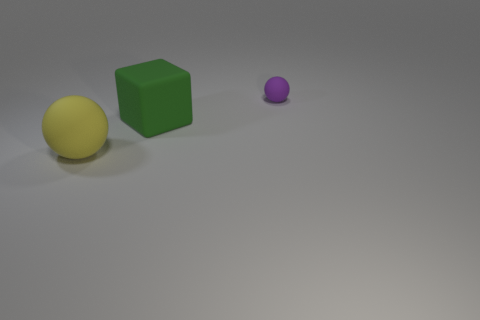What is the color of the matte object that is on the left side of the large matte thing behind the ball that is left of the tiny purple rubber sphere?
Give a very brief answer. Yellow. Is there a big green rubber object of the same shape as the yellow thing?
Your response must be concise. No. What number of tiny red matte blocks are there?
Your answer should be compact. 0. The yellow rubber object is what shape?
Make the answer very short. Sphere. How many balls have the same size as the yellow object?
Ensure brevity in your answer.  0. Is the shape of the small rubber thing the same as the large green rubber thing?
Your answer should be very brief. No. What color is the sphere that is on the right side of the ball that is to the left of the purple ball?
Offer a very short reply. Purple. There is a object that is right of the yellow matte thing and to the left of the tiny purple ball; how big is it?
Your response must be concise. Large. Are there any other things of the same color as the block?
Your answer should be very brief. No. What shape is the small object that is the same material as the large ball?
Offer a terse response. Sphere. 